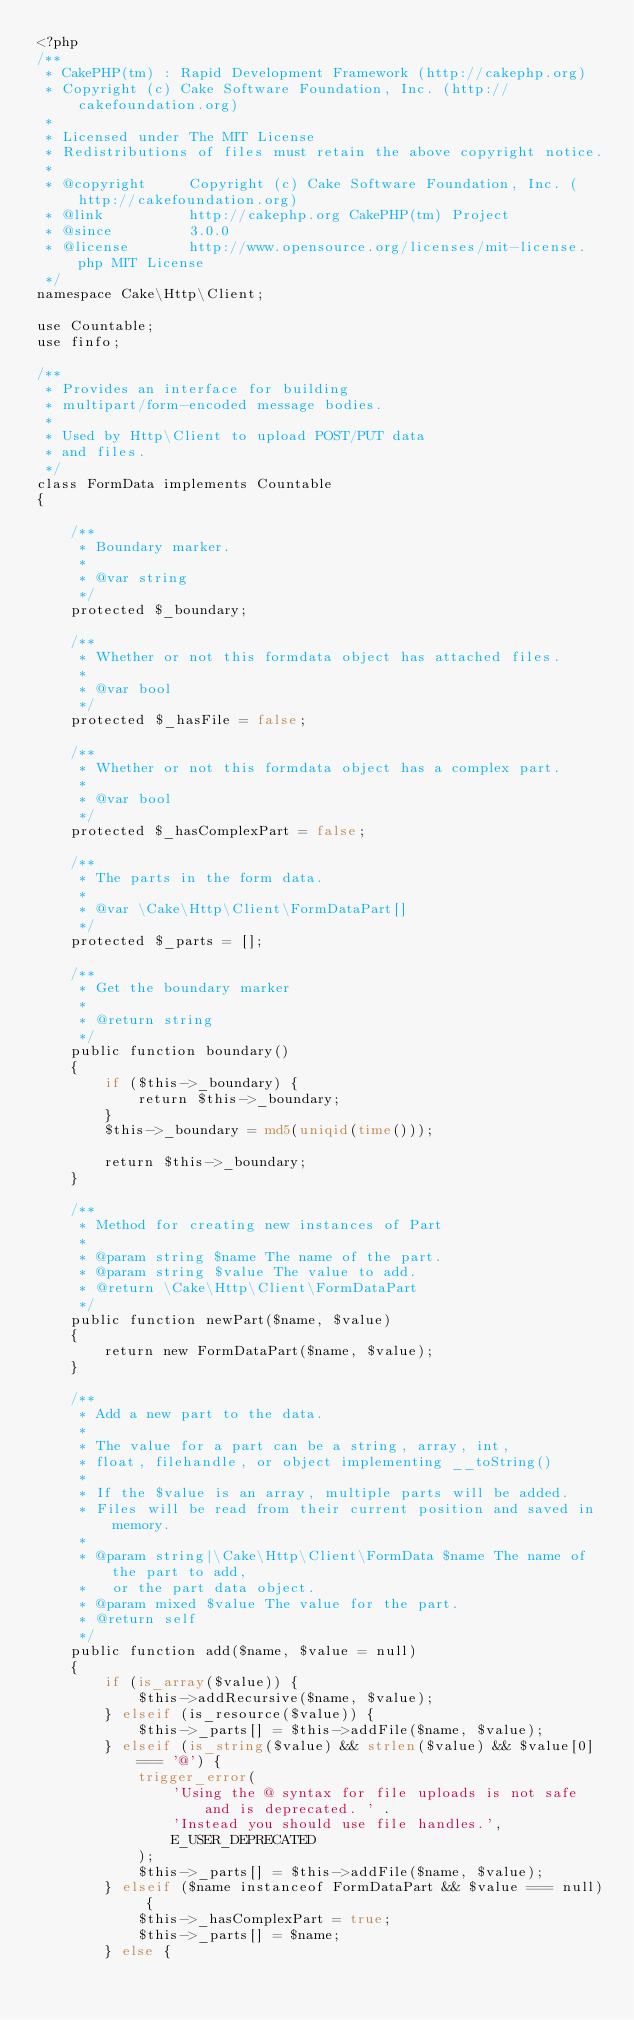<code> <loc_0><loc_0><loc_500><loc_500><_PHP_><?php
/**
 * CakePHP(tm) : Rapid Development Framework (http://cakephp.org)
 * Copyright (c) Cake Software Foundation, Inc. (http://cakefoundation.org)
 *
 * Licensed under The MIT License
 * Redistributions of files must retain the above copyright notice.
 *
 * @copyright     Copyright (c) Cake Software Foundation, Inc. (http://cakefoundation.org)
 * @link          http://cakephp.org CakePHP(tm) Project
 * @since         3.0.0
 * @license       http://www.opensource.org/licenses/mit-license.php MIT License
 */
namespace Cake\Http\Client;

use Countable;
use finfo;

/**
 * Provides an interface for building
 * multipart/form-encoded message bodies.
 *
 * Used by Http\Client to upload POST/PUT data
 * and files.
 */
class FormData implements Countable
{

    /**
     * Boundary marker.
     *
     * @var string
     */
    protected $_boundary;

    /**
     * Whether or not this formdata object has attached files.
     *
     * @var bool
     */
    protected $_hasFile = false;

    /**
     * Whether or not this formdata object has a complex part.
     *
     * @var bool
     */
    protected $_hasComplexPart = false;

    /**
     * The parts in the form data.
     *
     * @var \Cake\Http\Client\FormDataPart[]
     */
    protected $_parts = [];

    /**
     * Get the boundary marker
     *
     * @return string
     */
    public function boundary()
    {
        if ($this->_boundary) {
            return $this->_boundary;
        }
        $this->_boundary = md5(uniqid(time()));

        return $this->_boundary;
    }

    /**
     * Method for creating new instances of Part
     *
     * @param string $name The name of the part.
     * @param string $value The value to add.
     * @return \Cake\Http\Client\FormDataPart
     */
    public function newPart($name, $value)
    {
        return new FormDataPart($name, $value);
    }

    /**
     * Add a new part to the data.
     *
     * The value for a part can be a string, array, int,
     * float, filehandle, or object implementing __toString()
     *
     * If the $value is an array, multiple parts will be added.
     * Files will be read from their current position and saved in memory.
     *
     * @param string|\Cake\Http\Client\FormData $name The name of the part to add,
     *   or the part data object.
     * @param mixed $value The value for the part.
     * @return self
     */
    public function add($name, $value = null)
    {
        if (is_array($value)) {
            $this->addRecursive($name, $value);
        } elseif (is_resource($value)) {
            $this->_parts[] = $this->addFile($name, $value);
        } elseif (is_string($value) && strlen($value) && $value[0] === '@') {
            trigger_error(
                'Using the @ syntax for file uploads is not safe and is deprecated. ' .
                'Instead you should use file handles.',
                E_USER_DEPRECATED
            );
            $this->_parts[] = $this->addFile($name, $value);
        } elseif ($name instanceof FormDataPart && $value === null) {
            $this->_hasComplexPart = true;
            $this->_parts[] = $name;
        } else {</code> 